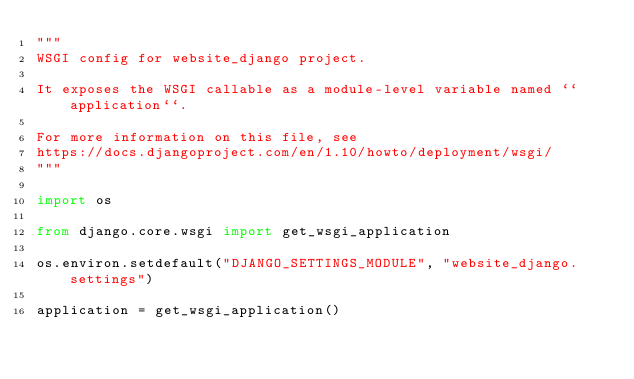Convert code to text. <code><loc_0><loc_0><loc_500><loc_500><_Python_>"""
WSGI config for website_django project.

It exposes the WSGI callable as a module-level variable named ``application``.

For more information on this file, see
https://docs.djangoproject.com/en/1.10/howto/deployment/wsgi/
"""

import os

from django.core.wsgi import get_wsgi_application

os.environ.setdefault("DJANGO_SETTINGS_MODULE", "website_django.settings")

application = get_wsgi_application()
</code> 